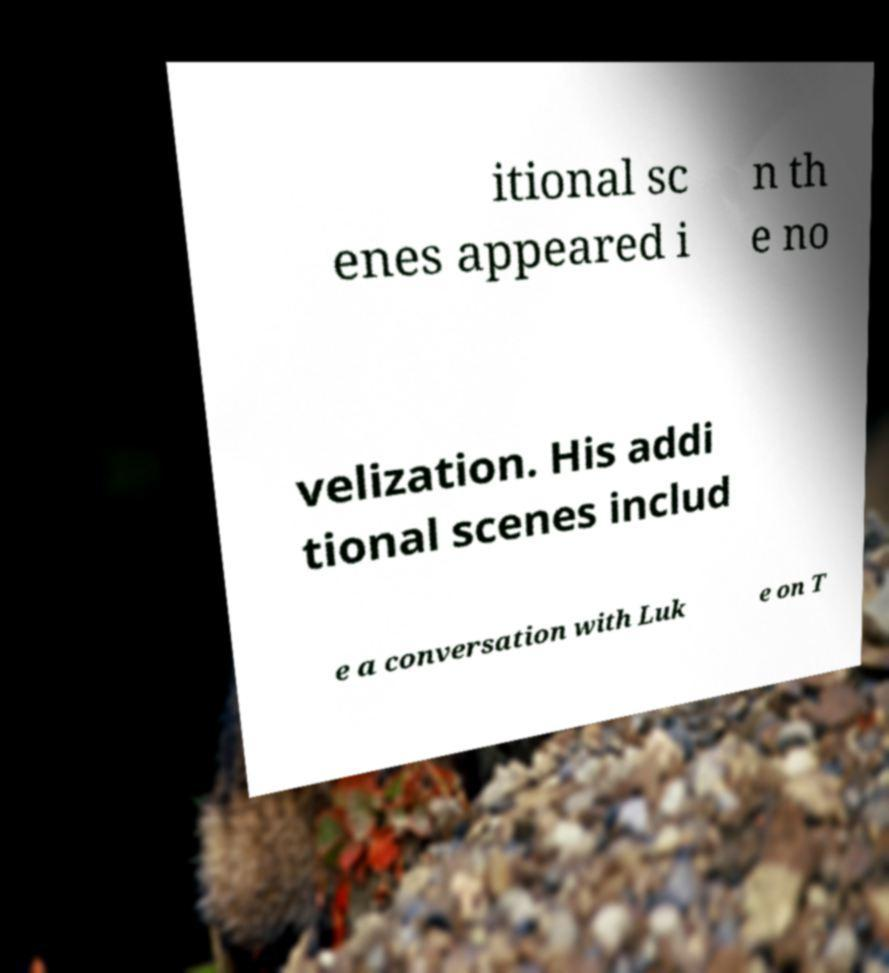For documentation purposes, I need the text within this image transcribed. Could you provide that? itional sc enes appeared i n th e no velization. His addi tional scenes includ e a conversation with Luk e on T 